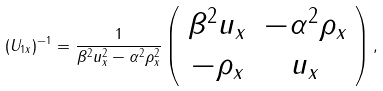<formula> <loc_0><loc_0><loc_500><loc_500>( U _ { 1 x } ) ^ { - 1 } = \frac { 1 } { \beta ^ { 2 } u ^ { 2 } _ { x } - \alpha ^ { 2 } \rho ^ { 2 } _ { x } } \left ( \begin{array} { c c } \beta ^ { 2 } u _ { x } & - \alpha ^ { 2 } \rho _ { x } \\ - \rho _ { x } & u _ { x } \end{array} \right ) ,</formula> 